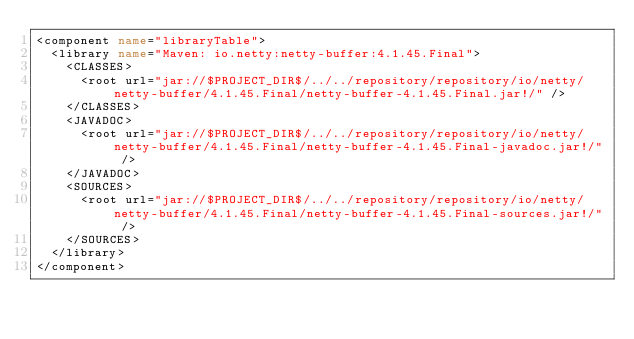Convert code to text. <code><loc_0><loc_0><loc_500><loc_500><_XML_><component name="libraryTable">
  <library name="Maven: io.netty:netty-buffer:4.1.45.Final">
    <CLASSES>
      <root url="jar://$PROJECT_DIR$/../../repository/repository/io/netty/netty-buffer/4.1.45.Final/netty-buffer-4.1.45.Final.jar!/" />
    </CLASSES>
    <JAVADOC>
      <root url="jar://$PROJECT_DIR$/../../repository/repository/io/netty/netty-buffer/4.1.45.Final/netty-buffer-4.1.45.Final-javadoc.jar!/" />
    </JAVADOC>
    <SOURCES>
      <root url="jar://$PROJECT_DIR$/../../repository/repository/io/netty/netty-buffer/4.1.45.Final/netty-buffer-4.1.45.Final-sources.jar!/" />
    </SOURCES>
  </library>
</component></code> 